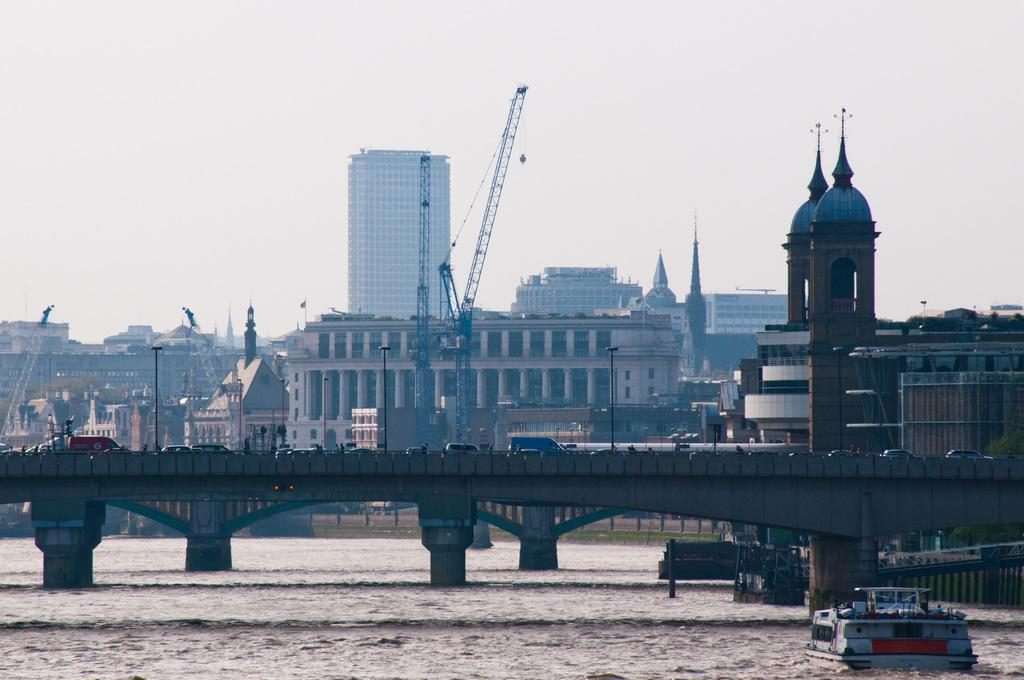What is the main subject of the image? The main subject of the image is a ship above the water. What else can be seen in the image besides the ship? Vehicles are present on a bridge, and there are buildings and cranes visible in the background. What is the condition of the sky in the image? The sky is visible in the background of the image. What type of education can be seen taking place on the ship in the image? There is no indication of education taking place on the ship in the image. Can you see a string attached to the cranes in the image? There is no mention of a string in the image, and it is not visible in the provided facts. 